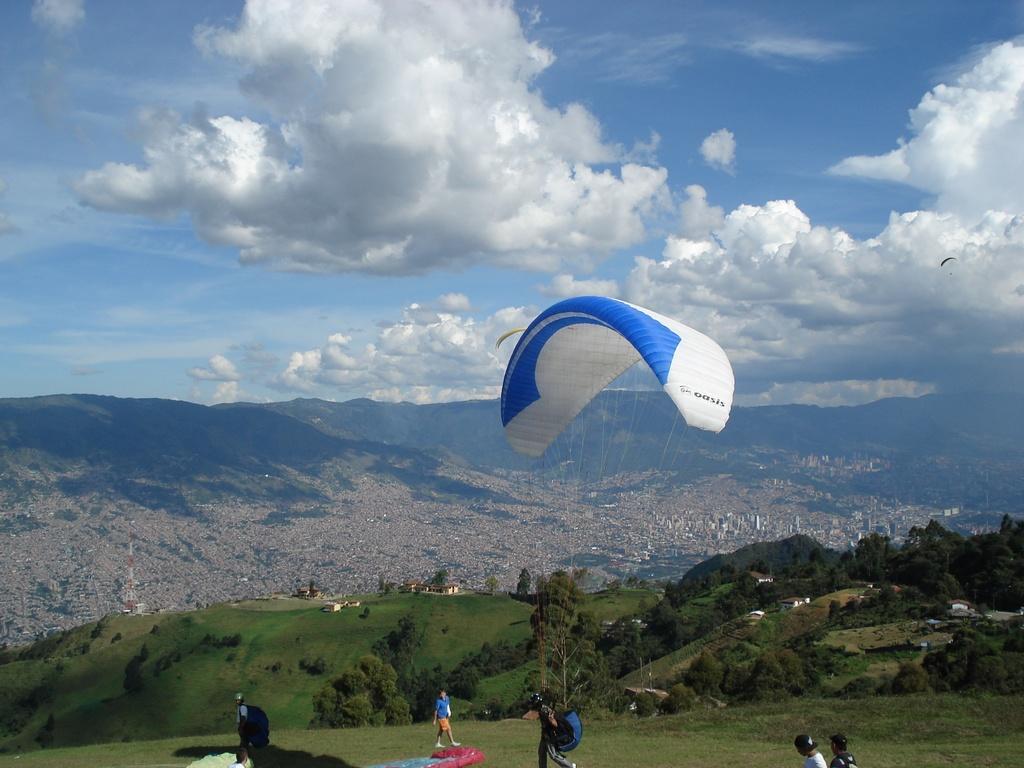Please provide a concise description of this image. In this image we can see the paraglider. And we can see some people. And we can see the grass, trees. And we can see the hill. And we can see the clouds in the sky. 